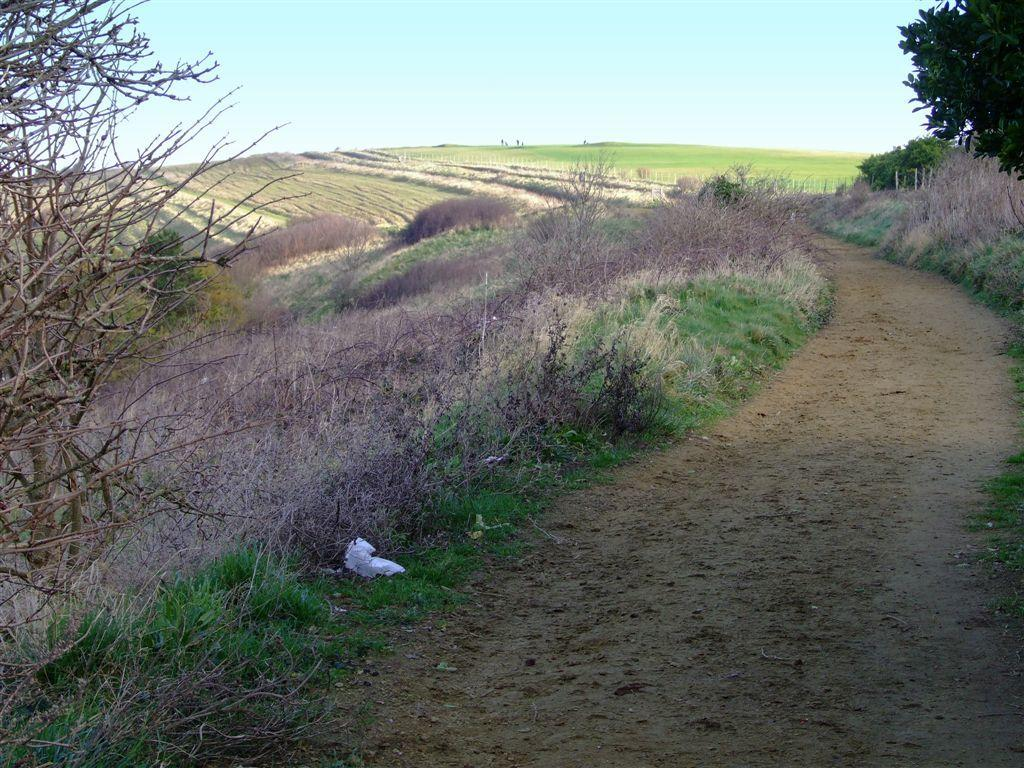What type of path is visible in the image? There is a walkway in the image. What can be seen in the distance behind the walkway? There are farm lands and trees in the background of the image. What is the condition of the sky in the image? The sky is clear and visible in the background of the image. What type of coal can be seen being transported on the walkway in the image? There is no coal present in the image; it features a walkway with farm lands, trees, and a clear sky in the background. 